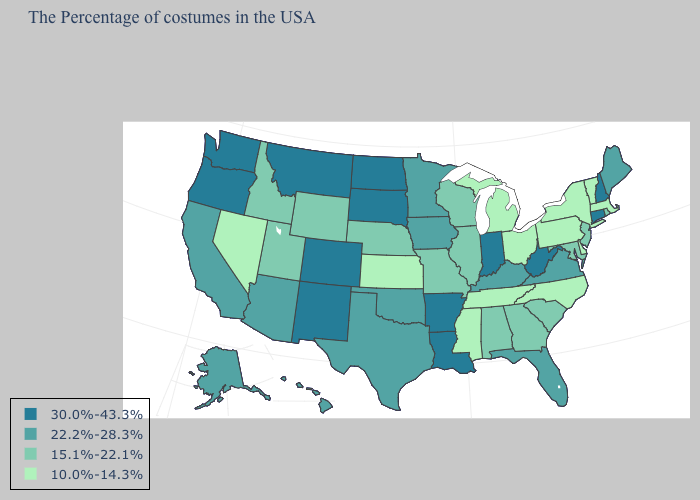Does Washington have the same value as New Mexico?
Write a very short answer. Yes. Does Louisiana have a higher value than Nevada?
Concise answer only. Yes. What is the value of Oregon?
Quick response, please. 30.0%-43.3%. Does the map have missing data?
Answer briefly. No. Does the map have missing data?
Quick response, please. No. Name the states that have a value in the range 22.2%-28.3%?
Quick response, please. Maine, Virginia, Florida, Kentucky, Minnesota, Iowa, Oklahoma, Texas, Arizona, California, Alaska, Hawaii. What is the highest value in states that border Delaware?
Concise answer only. 15.1%-22.1%. Name the states that have a value in the range 15.1%-22.1%?
Short answer required. Rhode Island, New Jersey, Maryland, South Carolina, Georgia, Alabama, Wisconsin, Illinois, Missouri, Nebraska, Wyoming, Utah, Idaho. Does Nevada have a lower value than Missouri?
Be succinct. Yes. Name the states that have a value in the range 22.2%-28.3%?
Be succinct. Maine, Virginia, Florida, Kentucky, Minnesota, Iowa, Oklahoma, Texas, Arizona, California, Alaska, Hawaii. Which states have the highest value in the USA?
Short answer required. New Hampshire, Connecticut, West Virginia, Indiana, Louisiana, Arkansas, South Dakota, North Dakota, Colorado, New Mexico, Montana, Washington, Oregon. What is the value of Louisiana?
Concise answer only. 30.0%-43.3%. What is the value of Michigan?
Write a very short answer. 10.0%-14.3%. What is the highest value in states that border Massachusetts?
Be succinct. 30.0%-43.3%. Does the map have missing data?
Concise answer only. No. 